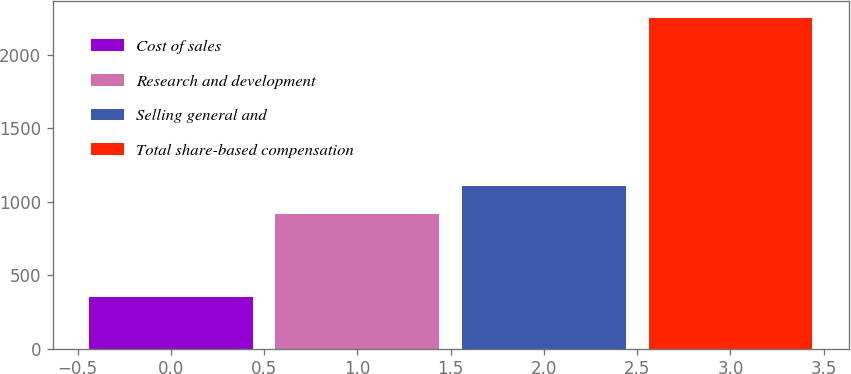Convert chart. <chart><loc_0><loc_0><loc_500><loc_500><bar_chart><fcel>Cost of sales<fcel>Research and development<fcel>Selling general and<fcel>Total share-based compensation<nl><fcel>350<fcel>917<fcel>1107.3<fcel>2253<nl></chart> 